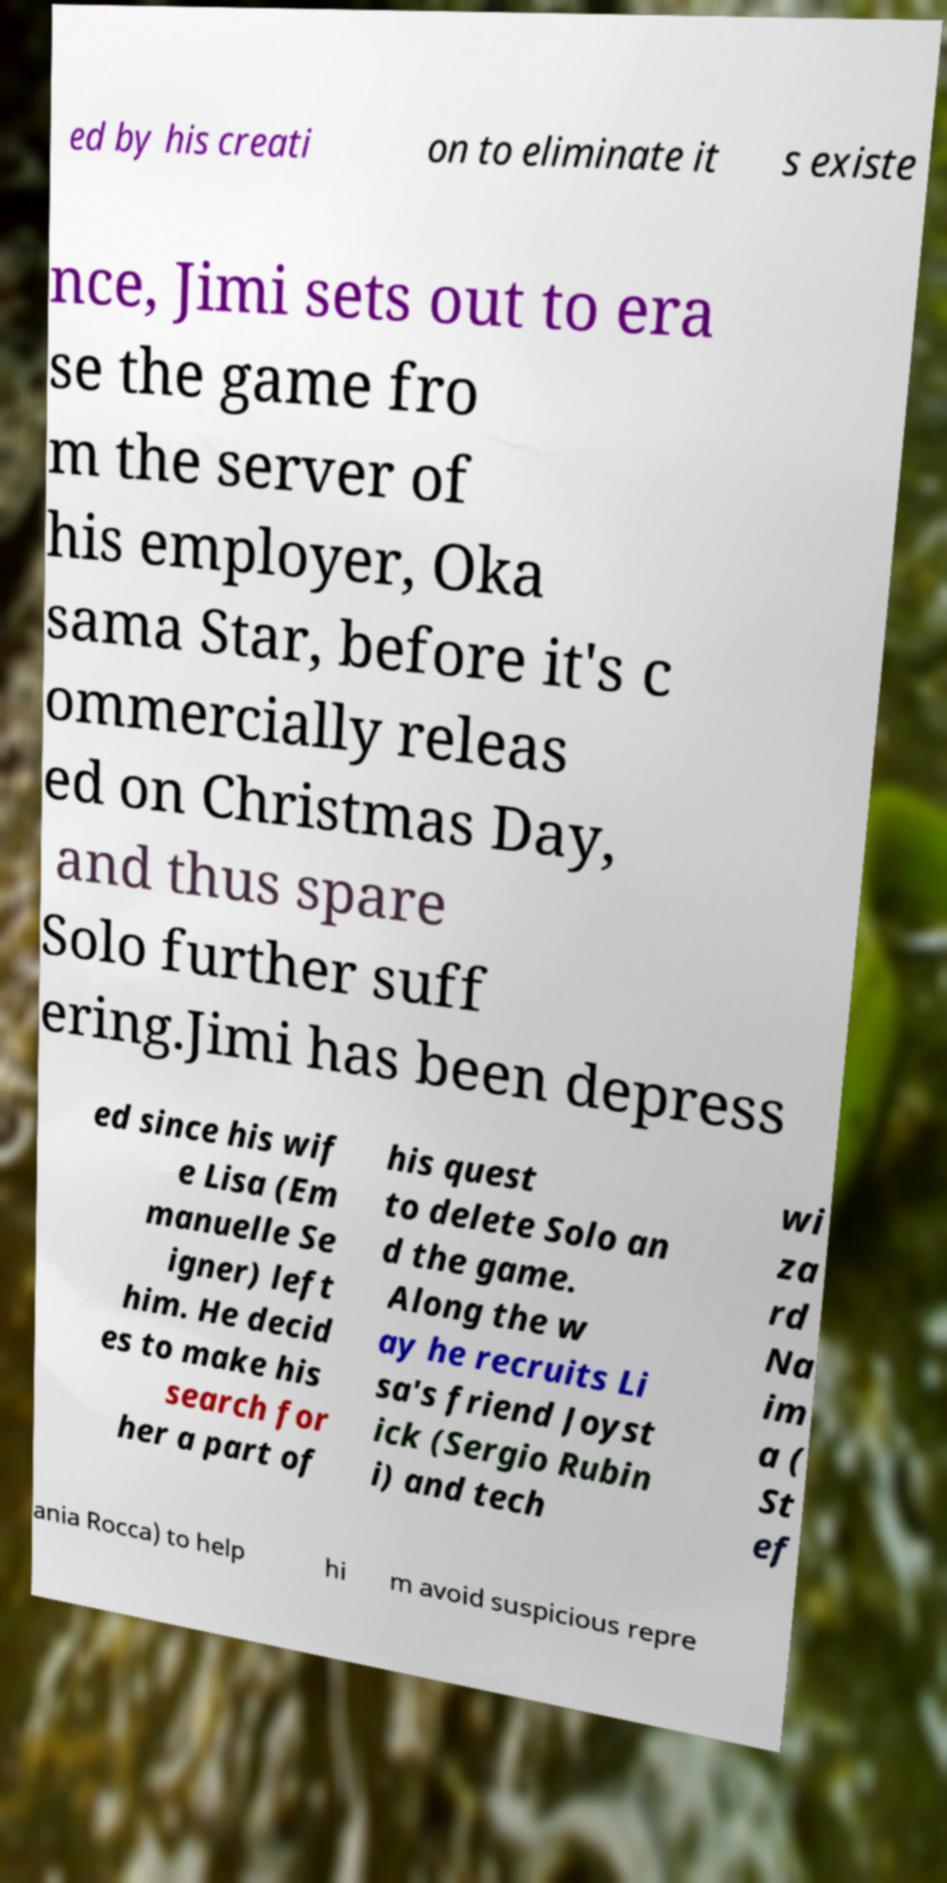What messages or text are displayed in this image? I need them in a readable, typed format. ed by his creati on to eliminate it s existe nce, Jimi sets out to era se the game fro m the server of his employer, Oka sama Star, before it's c ommercially releas ed on Christmas Day, and thus spare Solo further suff ering.Jimi has been depress ed since his wif e Lisa (Em manuelle Se igner) left him. He decid es to make his search for her a part of his quest to delete Solo an d the game. Along the w ay he recruits Li sa's friend Joyst ick (Sergio Rubin i) and tech wi za rd Na im a ( St ef ania Rocca) to help hi m avoid suspicious repre 